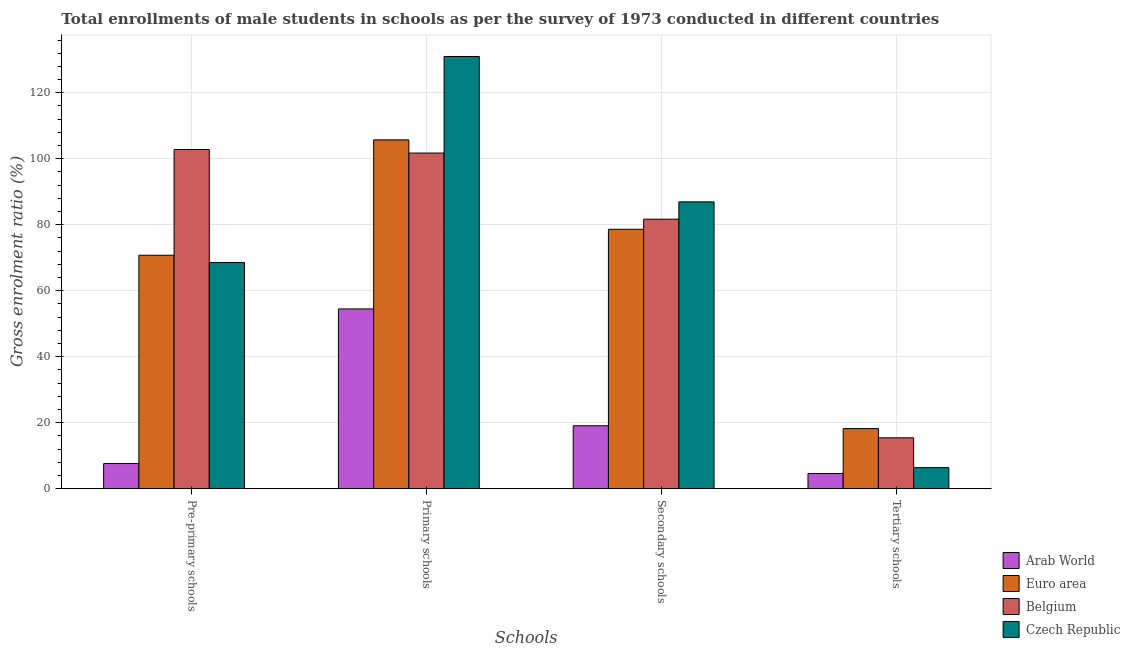Are the number of bars per tick equal to the number of legend labels?
Offer a terse response. Yes. Are the number of bars on each tick of the X-axis equal?
Your answer should be compact. Yes. How many bars are there on the 1st tick from the left?
Your response must be concise. 4. How many bars are there on the 3rd tick from the right?
Provide a short and direct response. 4. What is the label of the 4th group of bars from the left?
Offer a terse response. Tertiary schools. What is the gross enrolment ratio(male) in tertiary schools in Arab World?
Ensure brevity in your answer.  4.6. Across all countries, what is the maximum gross enrolment ratio(male) in secondary schools?
Ensure brevity in your answer.  86.94. Across all countries, what is the minimum gross enrolment ratio(male) in primary schools?
Your response must be concise. 54.49. In which country was the gross enrolment ratio(male) in primary schools maximum?
Ensure brevity in your answer.  Czech Republic. In which country was the gross enrolment ratio(male) in pre-primary schools minimum?
Make the answer very short. Arab World. What is the total gross enrolment ratio(male) in tertiary schools in the graph?
Give a very brief answer. 44.62. What is the difference between the gross enrolment ratio(male) in tertiary schools in Czech Republic and that in Euro area?
Offer a very short reply. -11.84. What is the difference between the gross enrolment ratio(male) in tertiary schools in Belgium and the gross enrolment ratio(male) in primary schools in Czech Republic?
Your response must be concise. -115.58. What is the average gross enrolment ratio(male) in tertiary schools per country?
Offer a terse response. 11.16. What is the difference between the gross enrolment ratio(male) in primary schools and gross enrolment ratio(male) in tertiary schools in Belgium?
Offer a terse response. 86.31. What is the ratio of the gross enrolment ratio(male) in secondary schools in Arab World to that in Czech Republic?
Your answer should be compact. 0.22. What is the difference between the highest and the second highest gross enrolment ratio(male) in secondary schools?
Make the answer very short. 5.25. What is the difference between the highest and the lowest gross enrolment ratio(male) in pre-primary schools?
Provide a short and direct response. 95.19. Is it the case that in every country, the sum of the gross enrolment ratio(male) in pre-primary schools and gross enrolment ratio(male) in primary schools is greater than the gross enrolment ratio(male) in secondary schools?
Provide a succinct answer. Yes. How many bars are there?
Make the answer very short. 16. What is the difference between two consecutive major ticks on the Y-axis?
Provide a short and direct response. 20. Does the graph contain grids?
Ensure brevity in your answer.  Yes. How are the legend labels stacked?
Give a very brief answer. Vertical. What is the title of the graph?
Provide a succinct answer. Total enrollments of male students in schools as per the survey of 1973 conducted in different countries. What is the label or title of the X-axis?
Offer a terse response. Schools. What is the Gross enrolment ratio (%) in Arab World in Pre-primary schools?
Keep it short and to the point. 7.62. What is the Gross enrolment ratio (%) of Euro area in Pre-primary schools?
Your answer should be very brief. 70.76. What is the Gross enrolment ratio (%) in Belgium in Pre-primary schools?
Give a very brief answer. 102.81. What is the Gross enrolment ratio (%) of Czech Republic in Pre-primary schools?
Your answer should be compact. 68.55. What is the Gross enrolment ratio (%) of Arab World in Primary schools?
Make the answer very short. 54.49. What is the Gross enrolment ratio (%) of Euro area in Primary schools?
Ensure brevity in your answer.  105.73. What is the Gross enrolment ratio (%) in Belgium in Primary schools?
Your response must be concise. 101.73. What is the Gross enrolment ratio (%) in Czech Republic in Primary schools?
Your response must be concise. 131. What is the Gross enrolment ratio (%) in Arab World in Secondary schools?
Your answer should be very brief. 19.07. What is the Gross enrolment ratio (%) in Euro area in Secondary schools?
Your answer should be compact. 78.63. What is the Gross enrolment ratio (%) of Belgium in Secondary schools?
Offer a terse response. 81.69. What is the Gross enrolment ratio (%) in Czech Republic in Secondary schools?
Offer a terse response. 86.94. What is the Gross enrolment ratio (%) in Arab World in Tertiary schools?
Ensure brevity in your answer.  4.6. What is the Gross enrolment ratio (%) in Euro area in Tertiary schools?
Ensure brevity in your answer.  18.22. What is the Gross enrolment ratio (%) of Belgium in Tertiary schools?
Offer a terse response. 15.42. What is the Gross enrolment ratio (%) of Czech Republic in Tertiary schools?
Your answer should be very brief. 6.38. Across all Schools, what is the maximum Gross enrolment ratio (%) of Arab World?
Provide a succinct answer. 54.49. Across all Schools, what is the maximum Gross enrolment ratio (%) in Euro area?
Your response must be concise. 105.73. Across all Schools, what is the maximum Gross enrolment ratio (%) in Belgium?
Your answer should be very brief. 102.81. Across all Schools, what is the maximum Gross enrolment ratio (%) of Czech Republic?
Your answer should be compact. 131. Across all Schools, what is the minimum Gross enrolment ratio (%) in Arab World?
Make the answer very short. 4.6. Across all Schools, what is the minimum Gross enrolment ratio (%) in Euro area?
Keep it short and to the point. 18.22. Across all Schools, what is the minimum Gross enrolment ratio (%) of Belgium?
Keep it short and to the point. 15.42. Across all Schools, what is the minimum Gross enrolment ratio (%) of Czech Republic?
Your response must be concise. 6.38. What is the total Gross enrolment ratio (%) of Arab World in the graph?
Offer a terse response. 85.78. What is the total Gross enrolment ratio (%) in Euro area in the graph?
Your response must be concise. 273.34. What is the total Gross enrolment ratio (%) of Belgium in the graph?
Your answer should be very brief. 301.65. What is the total Gross enrolment ratio (%) of Czech Republic in the graph?
Ensure brevity in your answer.  292.87. What is the difference between the Gross enrolment ratio (%) in Arab World in Pre-primary schools and that in Primary schools?
Provide a succinct answer. -46.87. What is the difference between the Gross enrolment ratio (%) in Euro area in Pre-primary schools and that in Primary schools?
Offer a very short reply. -34.98. What is the difference between the Gross enrolment ratio (%) of Belgium in Pre-primary schools and that in Primary schools?
Offer a very short reply. 1.08. What is the difference between the Gross enrolment ratio (%) of Czech Republic in Pre-primary schools and that in Primary schools?
Give a very brief answer. -62.46. What is the difference between the Gross enrolment ratio (%) of Arab World in Pre-primary schools and that in Secondary schools?
Your answer should be compact. -11.45. What is the difference between the Gross enrolment ratio (%) in Euro area in Pre-primary schools and that in Secondary schools?
Provide a succinct answer. -7.87. What is the difference between the Gross enrolment ratio (%) in Belgium in Pre-primary schools and that in Secondary schools?
Your answer should be very brief. 21.12. What is the difference between the Gross enrolment ratio (%) of Czech Republic in Pre-primary schools and that in Secondary schools?
Offer a very short reply. -18.39. What is the difference between the Gross enrolment ratio (%) of Arab World in Pre-primary schools and that in Tertiary schools?
Provide a short and direct response. 3.02. What is the difference between the Gross enrolment ratio (%) in Euro area in Pre-primary schools and that in Tertiary schools?
Your response must be concise. 52.54. What is the difference between the Gross enrolment ratio (%) in Belgium in Pre-primary schools and that in Tertiary schools?
Your response must be concise. 87.39. What is the difference between the Gross enrolment ratio (%) in Czech Republic in Pre-primary schools and that in Tertiary schools?
Provide a short and direct response. 62.16. What is the difference between the Gross enrolment ratio (%) in Arab World in Primary schools and that in Secondary schools?
Give a very brief answer. 35.41. What is the difference between the Gross enrolment ratio (%) of Euro area in Primary schools and that in Secondary schools?
Your answer should be compact. 27.1. What is the difference between the Gross enrolment ratio (%) in Belgium in Primary schools and that in Secondary schools?
Ensure brevity in your answer.  20.05. What is the difference between the Gross enrolment ratio (%) in Czech Republic in Primary schools and that in Secondary schools?
Your answer should be very brief. 44.07. What is the difference between the Gross enrolment ratio (%) in Arab World in Primary schools and that in Tertiary schools?
Keep it short and to the point. 49.89. What is the difference between the Gross enrolment ratio (%) of Euro area in Primary schools and that in Tertiary schools?
Give a very brief answer. 87.51. What is the difference between the Gross enrolment ratio (%) of Belgium in Primary schools and that in Tertiary schools?
Offer a terse response. 86.31. What is the difference between the Gross enrolment ratio (%) in Czech Republic in Primary schools and that in Tertiary schools?
Provide a succinct answer. 124.62. What is the difference between the Gross enrolment ratio (%) of Arab World in Secondary schools and that in Tertiary schools?
Give a very brief answer. 14.47. What is the difference between the Gross enrolment ratio (%) in Euro area in Secondary schools and that in Tertiary schools?
Ensure brevity in your answer.  60.41. What is the difference between the Gross enrolment ratio (%) of Belgium in Secondary schools and that in Tertiary schools?
Offer a terse response. 66.27. What is the difference between the Gross enrolment ratio (%) of Czech Republic in Secondary schools and that in Tertiary schools?
Ensure brevity in your answer.  80.56. What is the difference between the Gross enrolment ratio (%) in Arab World in Pre-primary schools and the Gross enrolment ratio (%) in Euro area in Primary schools?
Provide a short and direct response. -98.11. What is the difference between the Gross enrolment ratio (%) in Arab World in Pre-primary schools and the Gross enrolment ratio (%) in Belgium in Primary schools?
Offer a terse response. -94.11. What is the difference between the Gross enrolment ratio (%) of Arab World in Pre-primary schools and the Gross enrolment ratio (%) of Czech Republic in Primary schools?
Keep it short and to the point. -123.38. What is the difference between the Gross enrolment ratio (%) in Euro area in Pre-primary schools and the Gross enrolment ratio (%) in Belgium in Primary schools?
Offer a very short reply. -30.97. What is the difference between the Gross enrolment ratio (%) in Euro area in Pre-primary schools and the Gross enrolment ratio (%) in Czech Republic in Primary schools?
Provide a short and direct response. -60.25. What is the difference between the Gross enrolment ratio (%) in Belgium in Pre-primary schools and the Gross enrolment ratio (%) in Czech Republic in Primary schools?
Make the answer very short. -28.19. What is the difference between the Gross enrolment ratio (%) in Arab World in Pre-primary schools and the Gross enrolment ratio (%) in Euro area in Secondary schools?
Give a very brief answer. -71.01. What is the difference between the Gross enrolment ratio (%) in Arab World in Pre-primary schools and the Gross enrolment ratio (%) in Belgium in Secondary schools?
Ensure brevity in your answer.  -74.07. What is the difference between the Gross enrolment ratio (%) in Arab World in Pre-primary schools and the Gross enrolment ratio (%) in Czech Republic in Secondary schools?
Your answer should be compact. -79.32. What is the difference between the Gross enrolment ratio (%) in Euro area in Pre-primary schools and the Gross enrolment ratio (%) in Belgium in Secondary schools?
Provide a succinct answer. -10.93. What is the difference between the Gross enrolment ratio (%) of Euro area in Pre-primary schools and the Gross enrolment ratio (%) of Czech Republic in Secondary schools?
Offer a terse response. -16.18. What is the difference between the Gross enrolment ratio (%) of Belgium in Pre-primary schools and the Gross enrolment ratio (%) of Czech Republic in Secondary schools?
Ensure brevity in your answer.  15.87. What is the difference between the Gross enrolment ratio (%) of Arab World in Pre-primary schools and the Gross enrolment ratio (%) of Euro area in Tertiary schools?
Your answer should be very brief. -10.6. What is the difference between the Gross enrolment ratio (%) in Arab World in Pre-primary schools and the Gross enrolment ratio (%) in Belgium in Tertiary schools?
Offer a very short reply. -7.8. What is the difference between the Gross enrolment ratio (%) of Arab World in Pre-primary schools and the Gross enrolment ratio (%) of Czech Republic in Tertiary schools?
Keep it short and to the point. 1.24. What is the difference between the Gross enrolment ratio (%) in Euro area in Pre-primary schools and the Gross enrolment ratio (%) in Belgium in Tertiary schools?
Ensure brevity in your answer.  55.34. What is the difference between the Gross enrolment ratio (%) in Euro area in Pre-primary schools and the Gross enrolment ratio (%) in Czech Republic in Tertiary schools?
Make the answer very short. 64.38. What is the difference between the Gross enrolment ratio (%) in Belgium in Pre-primary schools and the Gross enrolment ratio (%) in Czech Republic in Tertiary schools?
Make the answer very short. 96.43. What is the difference between the Gross enrolment ratio (%) of Arab World in Primary schools and the Gross enrolment ratio (%) of Euro area in Secondary schools?
Keep it short and to the point. -24.14. What is the difference between the Gross enrolment ratio (%) of Arab World in Primary schools and the Gross enrolment ratio (%) of Belgium in Secondary schools?
Your response must be concise. -27.2. What is the difference between the Gross enrolment ratio (%) of Arab World in Primary schools and the Gross enrolment ratio (%) of Czech Republic in Secondary schools?
Make the answer very short. -32.45. What is the difference between the Gross enrolment ratio (%) in Euro area in Primary schools and the Gross enrolment ratio (%) in Belgium in Secondary schools?
Provide a short and direct response. 24.05. What is the difference between the Gross enrolment ratio (%) in Euro area in Primary schools and the Gross enrolment ratio (%) in Czech Republic in Secondary schools?
Keep it short and to the point. 18.8. What is the difference between the Gross enrolment ratio (%) of Belgium in Primary schools and the Gross enrolment ratio (%) of Czech Republic in Secondary schools?
Give a very brief answer. 14.79. What is the difference between the Gross enrolment ratio (%) in Arab World in Primary schools and the Gross enrolment ratio (%) in Euro area in Tertiary schools?
Provide a short and direct response. 36.27. What is the difference between the Gross enrolment ratio (%) of Arab World in Primary schools and the Gross enrolment ratio (%) of Belgium in Tertiary schools?
Your answer should be compact. 39.06. What is the difference between the Gross enrolment ratio (%) in Arab World in Primary schools and the Gross enrolment ratio (%) in Czech Republic in Tertiary schools?
Your response must be concise. 48.1. What is the difference between the Gross enrolment ratio (%) in Euro area in Primary schools and the Gross enrolment ratio (%) in Belgium in Tertiary schools?
Your response must be concise. 90.31. What is the difference between the Gross enrolment ratio (%) of Euro area in Primary schools and the Gross enrolment ratio (%) of Czech Republic in Tertiary schools?
Provide a succinct answer. 99.35. What is the difference between the Gross enrolment ratio (%) in Belgium in Primary schools and the Gross enrolment ratio (%) in Czech Republic in Tertiary schools?
Offer a very short reply. 95.35. What is the difference between the Gross enrolment ratio (%) in Arab World in Secondary schools and the Gross enrolment ratio (%) in Euro area in Tertiary schools?
Offer a terse response. 0.85. What is the difference between the Gross enrolment ratio (%) in Arab World in Secondary schools and the Gross enrolment ratio (%) in Belgium in Tertiary schools?
Provide a short and direct response. 3.65. What is the difference between the Gross enrolment ratio (%) in Arab World in Secondary schools and the Gross enrolment ratio (%) in Czech Republic in Tertiary schools?
Give a very brief answer. 12.69. What is the difference between the Gross enrolment ratio (%) in Euro area in Secondary schools and the Gross enrolment ratio (%) in Belgium in Tertiary schools?
Your response must be concise. 63.21. What is the difference between the Gross enrolment ratio (%) of Euro area in Secondary schools and the Gross enrolment ratio (%) of Czech Republic in Tertiary schools?
Provide a succinct answer. 72.25. What is the difference between the Gross enrolment ratio (%) of Belgium in Secondary schools and the Gross enrolment ratio (%) of Czech Republic in Tertiary schools?
Give a very brief answer. 75.31. What is the average Gross enrolment ratio (%) in Arab World per Schools?
Ensure brevity in your answer.  21.44. What is the average Gross enrolment ratio (%) of Euro area per Schools?
Your answer should be very brief. 68.34. What is the average Gross enrolment ratio (%) of Belgium per Schools?
Offer a terse response. 75.41. What is the average Gross enrolment ratio (%) of Czech Republic per Schools?
Keep it short and to the point. 73.22. What is the difference between the Gross enrolment ratio (%) in Arab World and Gross enrolment ratio (%) in Euro area in Pre-primary schools?
Your answer should be very brief. -63.14. What is the difference between the Gross enrolment ratio (%) of Arab World and Gross enrolment ratio (%) of Belgium in Pre-primary schools?
Provide a succinct answer. -95.19. What is the difference between the Gross enrolment ratio (%) in Arab World and Gross enrolment ratio (%) in Czech Republic in Pre-primary schools?
Give a very brief answer. -60.93. What is the difference between the Gross enrolment ratio (%) of Euro area and Gross enrolment ratio (%) of Belgium in Pre-primary schools?
Provide a short and direct response. -32.05. What is the difference between the Gross enrolment ratio (%) in Euro area and Gross enrolment ratio (%) in Czech Republic in Pre-primary schools?
Keep it short and to the point. 2.21. What is the difference between the Gross enrolment ratio (%) of Belgium and Gross enrolment ratio (%) of Czech Republic in Pre-primary schools?
Your answer should be compact. 34.26. What is the difference between the Gross enrolment ratio (%) in Arab World and Gross enrolment ratio (%) in Euro area in Primary schools?
Your answer should be very brief. -51.25. What is the difference between the Gross enrolment ratio (%) in Arab World and Gross enrolment ratio (%) in Belgium in Primary schools?
Ensure brevity in your answer.  -47.25. What is the difference between the Gross enrolment ratio (%) in Arab World and Gross enrolment ratio (%) in Czech Republic in Primary schools?
Provide a short and direct response. -76.52. What is the difference between the Gross enrolment ratio (%) of Euro area and Gross enrolment ratio (%) of Belgium in Primary schools?
Provide a short and direct response. 4. What is the difference between the Gross enrolment ratio (%) of Euro area and Gross enrolment ratio (%) of Czech Republic in Primary schools?
Ensure brevity in your answer.  -25.27. What is the difference between the Gross enrolment ratio (%) in Belgium and Gross enrolment ratio (%) in Czech Republic in Primary schools?
Make the answer very short. -29.27. What is the difference between the Gross enrolment ratio (%) in Arab World and Gross enrolment ratio (%) in Euro area in Secondary schools?
Your answer should be compact. -59.56. What is the difference between the Gross enrolment ratio (%) in Arab World and Gross enrolment ratio (%) in Belgium in Secondary schools?
Provide a short and direct response. -62.61. What is the difference between the Gross enrolment ratio (%) of Arab World and Gross enrolment ratio (%) of Czech Republic in Secondary schools?
Your response must be concise. -67.87. What is the difference between the Gross enrolment ratio (%) in Euro area and Gross enrolment ratio (%) in Belgium in Secondary schools?
Provide a short and direct response. -3.06. What is the difference between the Gross enrolment ratio (%) in Euro area and Gross enrolment ratio (%) in Czech Republic in Secondary schools?
Offer a terse response. -8.31. What is the difference between the Gross enrolment ratio (%) of Belgium and Gross enrolment ratio (%) of Czech Republic in Secondary schools?
Provide a short and direct response. -5.25. What is the difference between the Gross enrolment ratio (%) of Arab World and Gross enrolment ratio (%) of Euro area in Tertiary schools?
Provide a succinct answer. -13.62. What is the difference between the Gross enrolment ratio (%) in Arab World and Gross enrolment ratio (%) in Belgium in Tertiary schools?
Your answer should be compact. -10.82. What is the difference between the Gross enrolment ratio (%) in Arab World and Gross enrolment ratio (%) in Czech Republic in Tertiary schools?
Ensure brevity in your answer.  -1.78. What is the difference between the Gross enrolment ratio (%) in Euro area and Gross enrolment ratio (%) in Belgium in Tertiary schools?
Make the answer very short. 2.8. What is the difference between the Gross enrolment ratio (%) in Euro area and Gross enrolment ratio (%) in Czech Republic in Tertiary schools?
Your answer should be very brief. 11.84. What is the difference between the Gross enrolment ratio (%) in Belgium and Gross enrolment ratio (%) in Czech Republic in Tertiary schools?
Make the answer very short. 9.04. What is the ratio of the Gross enrolment ratio (%) in Arab World in Pre-primary schools to that in Primary schools?
Your response must be concise. 0.14. What is the ratio of the Gross enrolment ratio (%) in Euro area in Pre-primary schools to that in Primary schools?
Offer a very short reply. 0.67. What is the ratio of the Gross enrolment ratio (%) in Belgium in Pre-primary schools to that in Primary schools?
Offer a very short reply. 1.01. What is the ratio of the Gross enrolment ratio (%) of Czech Republic in Pre-primary schools to that in Primary schools?
Provide a short and direct response. 0.52. What is the ratio of the Gross enrolment ratio (%) in Arab World in Pre-primary schools to that in Secondary schools?
Your answer should be very brief. 0.4. What is the ratio of the Gross enrolment ratio (%) of Euro area in Pre-primary schools to that in Secondary schools?
Your answer should be compact. 0.9. What is the ratio of the Gross enrolment ratio (%) of Belgium in Pre-primary schools to that in Secondary schools?
Provide a succinct answer. 1.26. What is the ratio of the Gross enrolment ratio (%) of Czech Republic in Pre-primary schools to that in Secondary schools?
Your answer should be very brief. 0.79. What is the ratio of the Gross enrolment ratio (%) of Arab World in Pre-primary schools to that in Tertiary schools?
Provide a succinct answer. 1.66. What is the ratio of the Gross enrolment ratio (%) in Euro area in Pre-primary schools to that in Tertiary schools?
Offer a terse response. 3.88. What is the ratio of the Gross enrolment ratio (%) of Belgium in Pre-primary schools to that in Tertiary schools?
Provide a short and direct response. 6.67. What is the ratio of the Gross enrolment ratio (%) of Czech Republic in Pre-primary schools to that in Tertiary schools?
Offer a terse response. 10.74. What is the ratio of the Gross enrolment ratio (%) of Arab World in Primary schools to that in Secondary schools?
Offer a terse response. 2.86. What is the ratio of the Gross enrolment ratio (%) in Euro area in Primary schools to that in Secondary schools?
Your answer should be very brief. 1.34. What is the ratio of the Gross enrolment ratio (%) of Belgium in Primary schools to that in Secondary schools?
Give a very brief answer. 1.25. What is the ratio of the Gross enrolment ratio (%) in Czech Republic in Primary schools to that in Secondary schools?
Your response must be concise. 1.51. What is the ratio of the Gross enrolment ratio (%) in Arab World in Primary schools to that in Tertiary schools?
Your answer should be very brief. 11.85. What is the ratio of the Gross enrolment ratio (%) of Euro area in Primary schools to that in Tertiary schools?
Offer a very short reply. 5.8. What is the ratio of the Gross enrolment ratio (%) of Belgium in Primary schools to that in Tertiary schools?
Your response must be concise. 6.6. What is the ratio of the Gross enrolment ratio (%) of Czech Republic in Primary schools to that in Tertiary schools?
Ensure brevity in your answer.  20.52. What is the ratio of the Gross enrolment ratio (%) of Arab World in Secondary schools to that in Tertiary schools?
Provide a succinct answer. 4.15. What is the ratio of the Gross enrolment ratio (%) of Euro area in Secondary schools to that in Tertiary schools?
Provide a succinct answer. 4.32. What is the ratio of the Gross enrolment ratio (%) of Belgium in Secondary schools to that in Tertiary schools?
Give a very brief answer. 5.3. What is the ratio of the Gross enrolment ratio (%) in Czech Republic in Secondary schools to that in Tertiary schools?
Give a very brief answer. 13.62. What is the difference between the highest and the second highest Gross enrolment ratio (%) in Arab World?
Make the answer very short. 35.41. What is the difference between the highest and the second highest Gross enrolment ratio (%) of Euro area?
Provide a succinct answer. 27.1. What is the difference between the highest and the second highest Gross enrolment ratio (%) of Belgium?
Give a very brief answer. 1.08. What is the difference between the highest and the second highest Gross enrolment ratio (%) in Czech Republic?
Your answer should be very brief. 44.07. What is the difference between the highest and the lowest Gross enrolment ratio (%) in Arab World?
Your answer should be very brief. 49.89. What is the difference between the highest and the lowest Gross enrolment ratio (%) of Euro area?
Provide a short and direct response. 87.51. What is the difference between the highest and the lowest Gross enrolment ratio (%) of Belgium?
Provide a short and direct response. 87.39. What is the difference between the highest and the lowest Gross enrolment ratio (%) in Czech Republic?
Provide a succinct answer. 124.62. 